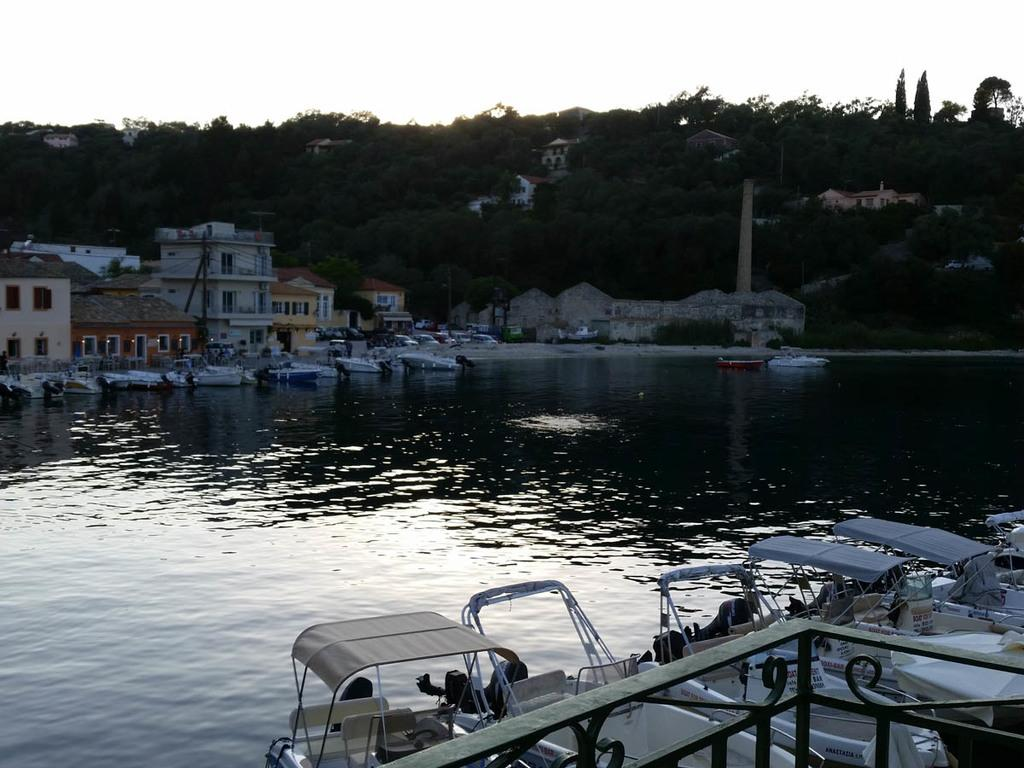What is on the water in the image? There are boats on the water in the image. What can be seen behind the boats? There are buildings behind the boats. What is the pole with cables used for in the image? The pole with cables is likely used for supporting electrical or communication lines. What type of vegetation is behind the pole and buildings? There are trees behind the pole and buildings. What is visible behind the trees? The sky is visible behind the trees. What type of amusement can be seen in the image? There is no amusement park or any amusement-related objects present in the image. What is the cause of the boats floating in the image? The boats are floating due to the buoyancy of the water, not because of any specific cause mentioned in the image. 